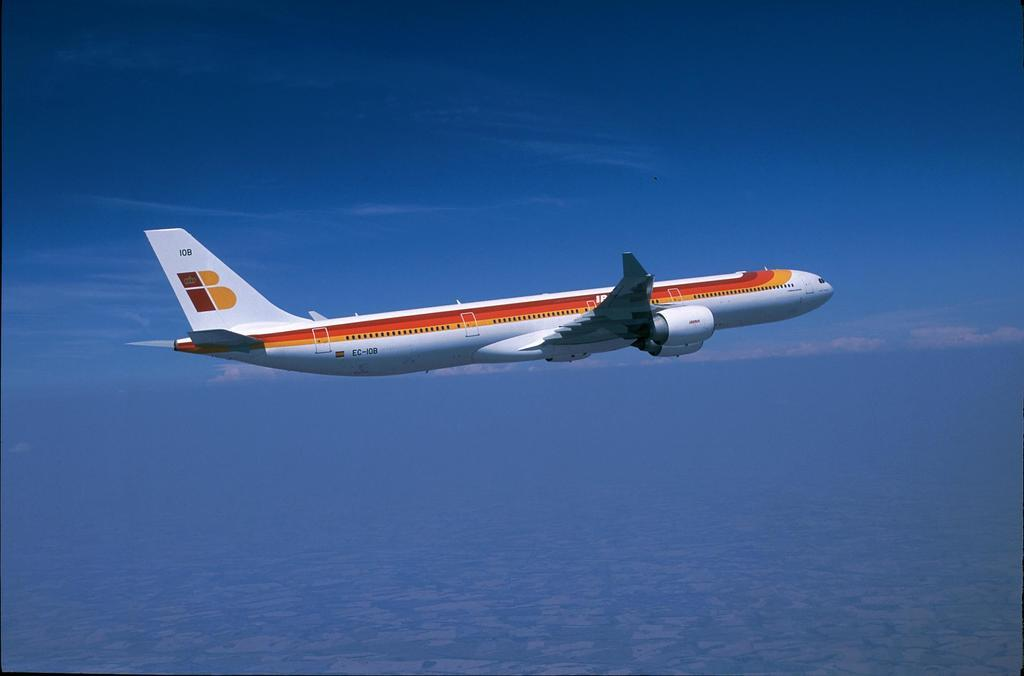What is the main subject of the image? The main subject of the image is a plane. What colors can be seen on the plane? The plane is in white and red color. Where is the plane located in the image? The plane is in the sky. What can be seen in the background of the image? There are clouds in the sky in the background of the image. What type of pet can be seen sitting on the wing of the plane in the image? There is no pet visible on the wing of the plane in the image. 